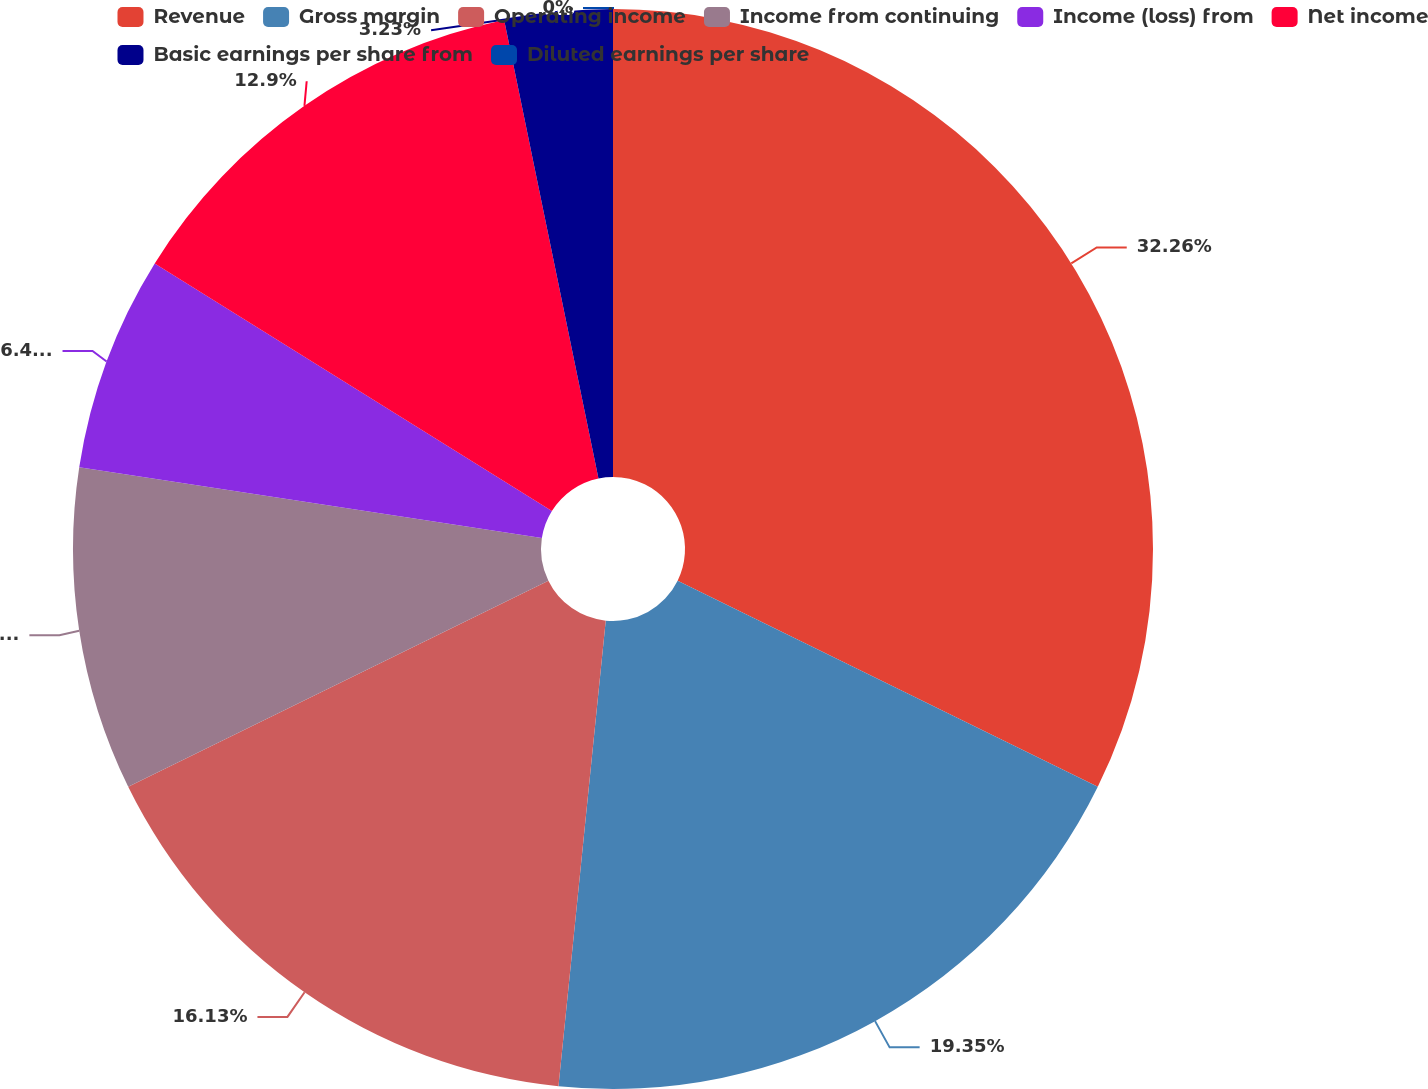Convert chart to OTSL. <chart><loc_0><loc_0><loc_500><loc_500><pie_chart><fcel>Revenue<fcel>Gross margin<fcel>Operating income<fcel>Income from continuing<fcel>Income (loss) from<fcel>Net income<fcel>Basic earnings per share from<fcel>Diluted earnings per share<nl><fcel>32.26%<fcel>19.35%<fcel>16.13%<fcel>9.68%<fcel>6.45%<fcel>12.9%<fcel>3.23%<fcel>0.0%<nl></chart> 